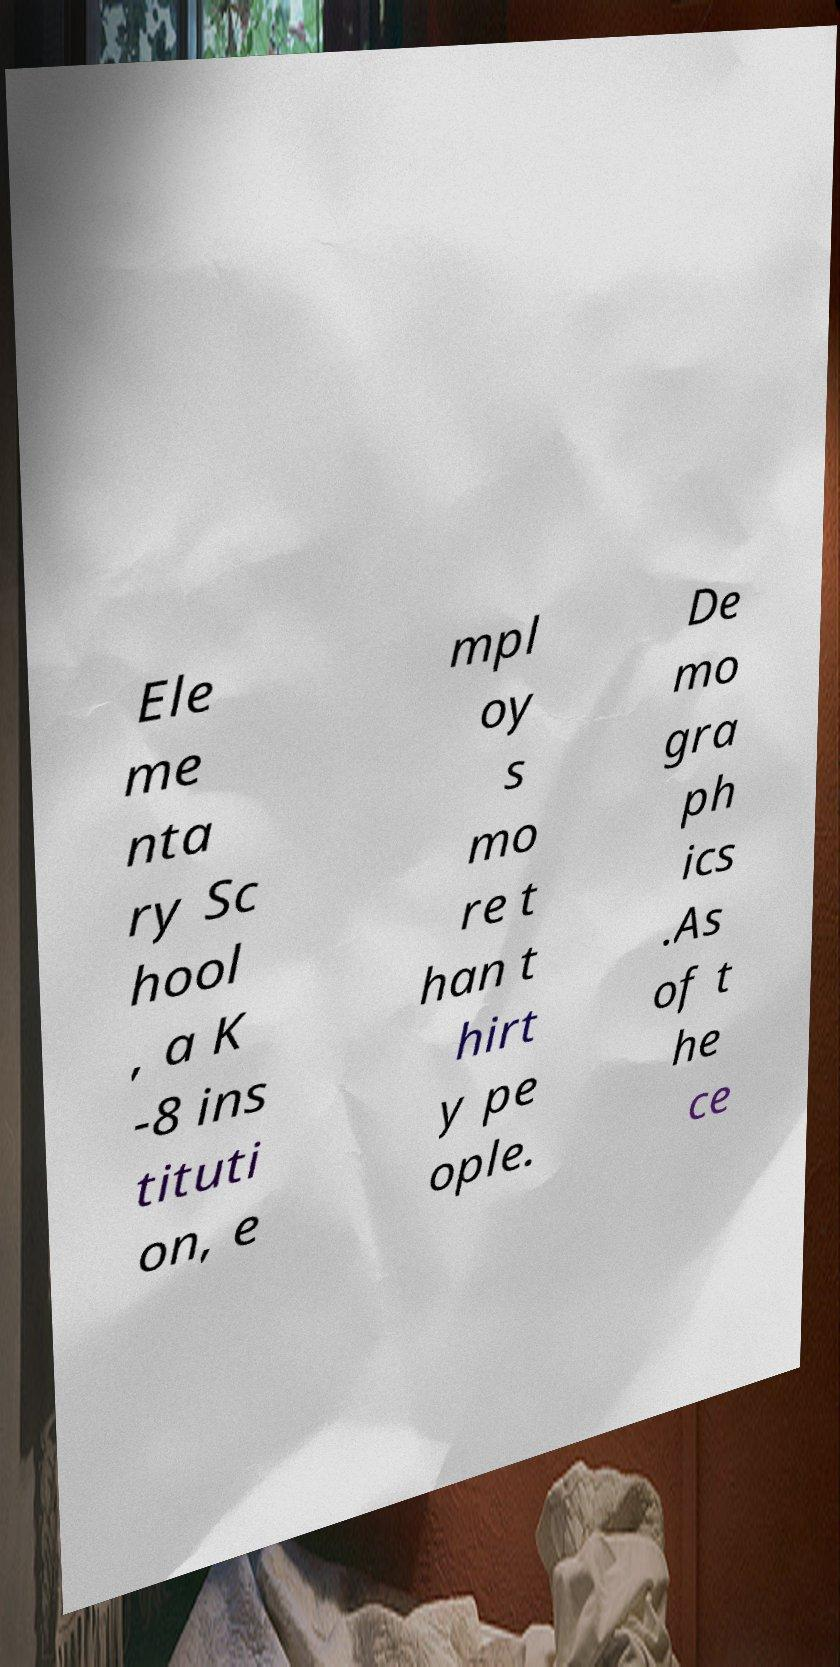Could you assist in decoding the text presented in this image and type it out clearly? Ele me nta ry Sc hool , a K -8 ins tituti on, e mpl oy s mo re t han t hirt y pe ople. De mo gra ph ics .As of t he ce 